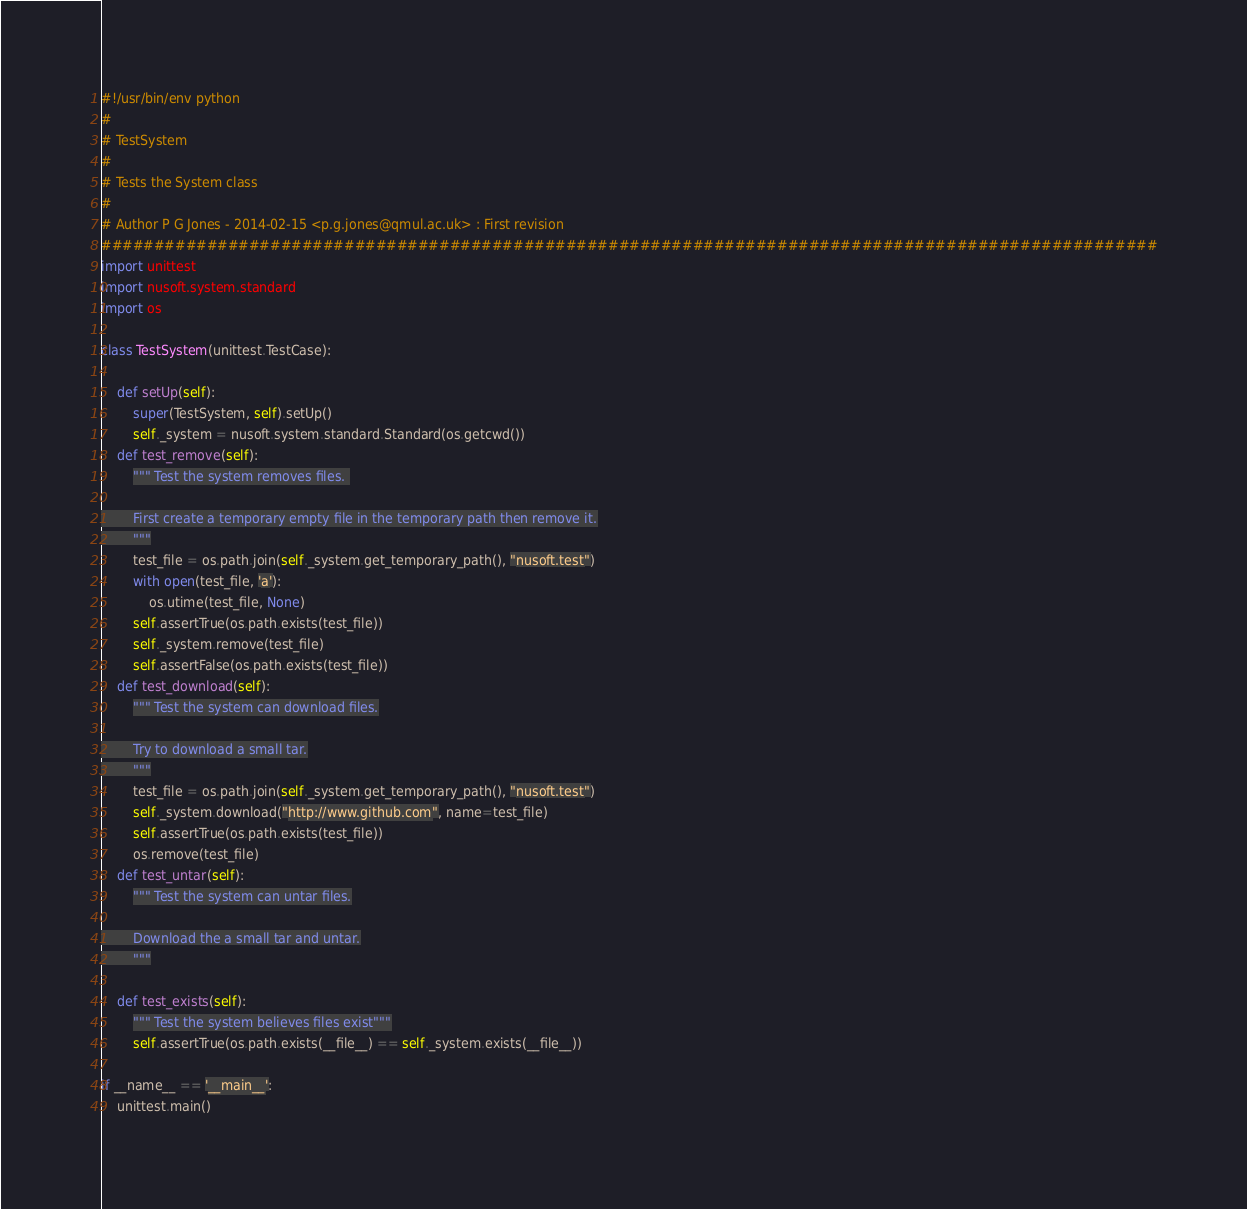<code> <loc_0><loc_0><loc_500><loc_500><_Python_>#!/usr/bin/env python
#
# TestSystem
#
# Tests the System class
#
# Author P G Jones - 2014-02-15 <p.g.jones@qmul.ac.uk> : First revision
####################################################################################################
import unittest
import nusoft.system.standard
import os

class TestSystem(unittest.TestCase):
    
    def setUp(self):
        super(TestSystem, self).setUp()
        self._system = nusoft.system.standard.Standard(os.getcwd())
    def test_remove(self):
        """ Test the system removes files. 

        First create a temporary empty file in the temporary path then remove it.
        """
        test_file = os.path.join(self._system.get_temporary_path(), "nusoft.test")
        with open(test_file, 'a'):
            os.utime(test_file, None)
        self.assertTrue(os.path.exists(test_file))
        self._system.remove(test_file)
        self.assertFalse(os.path.exists(test_file))
    def test_download(self):
        """ Test the system can download files.

        Try to download a small tar.
        """
        test_file = os.path.join(self._system.get_temporary_path(), "nusoft.test")
        self._system.download("http://www.github.com", name=test_file)
        self.assertTrue(os.path.exists(test_file))
        os.remove(test_file)
    def test_untar(self):
        """ Test the system can untar files.

        Download the a small tar and untar.
        """
        
    def test_exists(self):
        """ Test the system believes files exist"""
        self.assertTrue(os.path.exists(__file__) == self._system.exists(__file__))

if __name__ == '__main__':
    unittest.main()
</code> 